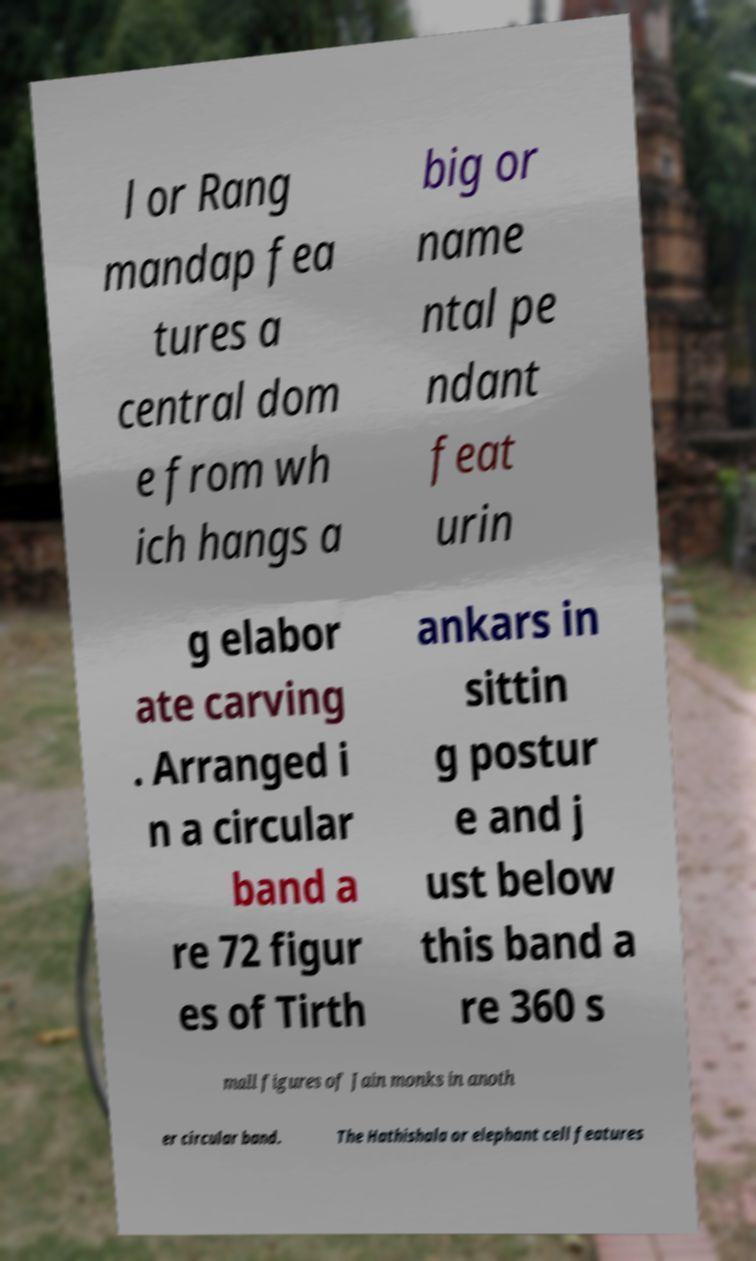I need the written content from this picture converted into text. Can you do that? l or Rang mandap fea tures a central dom e from wh ich hangs a big or name ntal pe ndant feat urin g elabor ate carving . Arranged i n a circular band a re 72 figur es of Tirth ankars in sittin g postur e and j ust below this band a re 360 s mall figures of Jain monks in anoth er circular band. The Hathishala or elephant cell features 